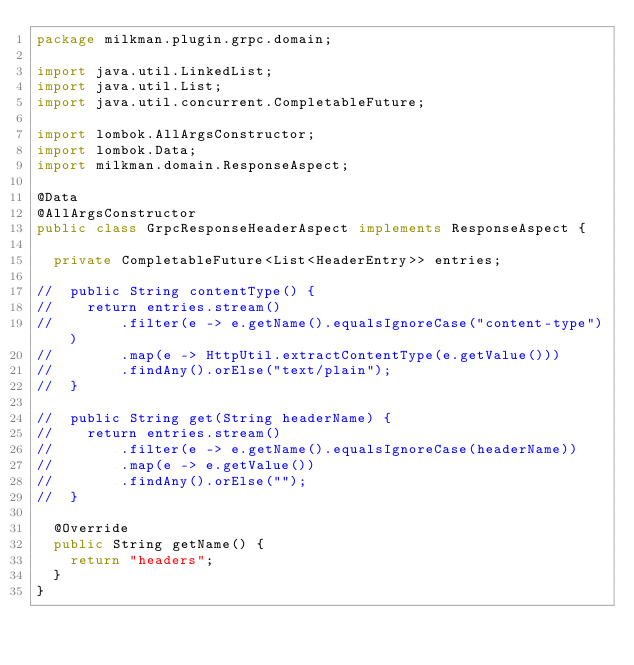<code> <loc_0><loc_0><loc_500><loc_500><_Java_>package milkman.plugin.grpc.domain;

import java.util.LinkedList;
import java.util.List;
import java.util.concurrent.CompletableFuture;

import lombok.AllArgsConstructor;
import lombok.Data;
import milkman.domain.ResponseAspect;

@Data
@AllArgsConstructor
public class GrpcResponseHeaderAspect implements ResponseAspect {
	
	private CompletableFuture<List<HeaderEntry>> entries;
	
//	public String contentType() {
//		return entries.stream()
//				.filter(e -> e.getName().equalsIgnoreCase("content-type"))
//				.map(e -> HttpUtil.extractContentType(e.getValue()))
//				.findAny().orElse("text/plain");
//	}

//	public String get(String headerName) {
//		return entries.stream()
//				.filter(e -> e.getName().equalsIgnoreCase(headerName))
//				.map(e -> e.getValue())
//				.findAny().orElse("");
//	}

	@Override
	public String getName() {
		return "headers";
	}
}
</code> 